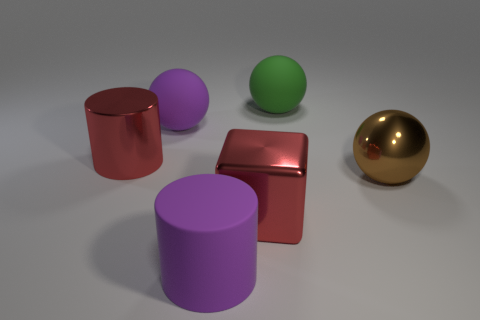What might be the context or purpose of this arrangement of objects? This arrangement could serve multiple purposes. It might be a visual demonstration of shapes and colors for educational purposes, a setup for practicing digital rendering techniques, or simply an artistic composition focusing on form and color interaction. How do the different colors of the objects affect the overall mood of the image? The mixture of colors, including the vivid green and purple alongside the metallic gold and subdued red, creates an interesting palette that is both pleasing and engaging. This variety in color can evoke a sense of curiosity and gives the image a playful and experimental character. 